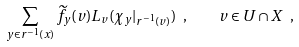Convert formula to latex. <formula><loc_0><loc_0><loc_500><loc_500>\sum _ { y \in r ^ { - 1 } ( x ) } \widetilde { f } _ { y } ( v ) L _ { v } ( \chi _ { y } | _ { r ^ { - 1 } ( v ) } ) \ , \quad v \in U \cap X \ ,</formula> 